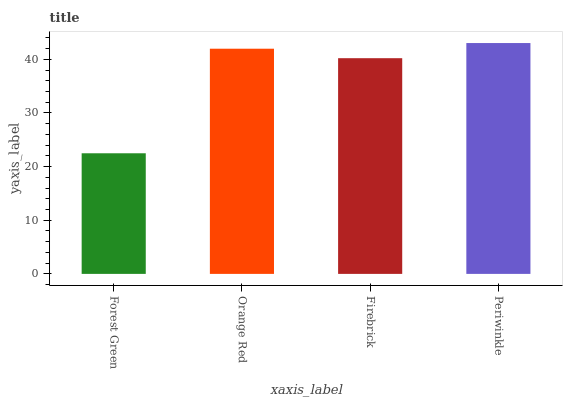Is Forest Green the minimum?
Answer yes or no. Yes. Is Periwinkle the maximum?
Answer yes or no. Yes. Is Orange Red the minimum?
Answer yes or no. No. Is Orange Red the maximum?
Answer yes or no. No. Is Orange Red greater than Forest Green?
Answer yes or no. Yes. Is Forest Green less than Orange Red?
Answer yes or no. Yes. Is Forest Green greater than Orange Red?
Answer yes or no. No. Is Orange Red less than Forest Green?
Answer yes or no. No. Is Orange Red the high median?
Answer yes or no. Yes. Is Firebrick the low median?
Answer yes or no. Yes. Is Firebrick the high median?
Answer yes or no. No. Is Forest Green the low median?
Answer yes or no. No. 